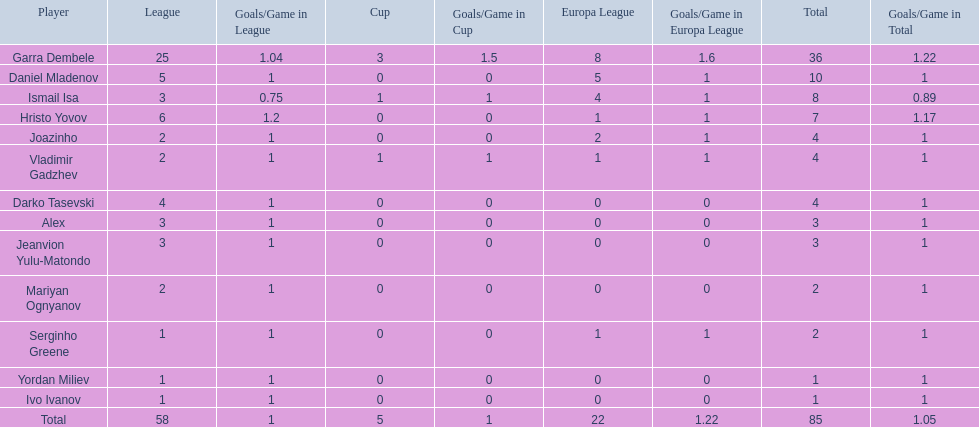What league is 2? 2, 2, 2. Which cup is less than 1? 0, 0. Which total is 2? 2. Who is the player? Mariyan Ognyanov. 